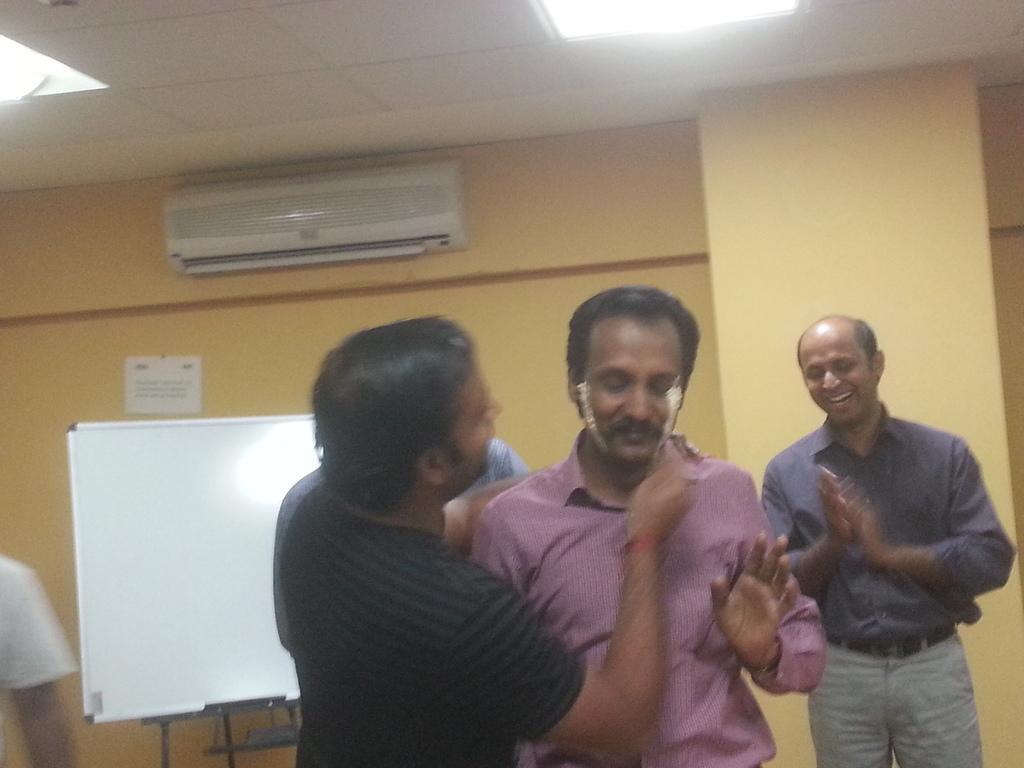Describe this image in one or two sentences. In the foreground of the image there are people standing. There is a white color board. In the background of the image there is a wall. There is a paper with some text. There is an AC. At the top of the image there is a ceiling with lights. 